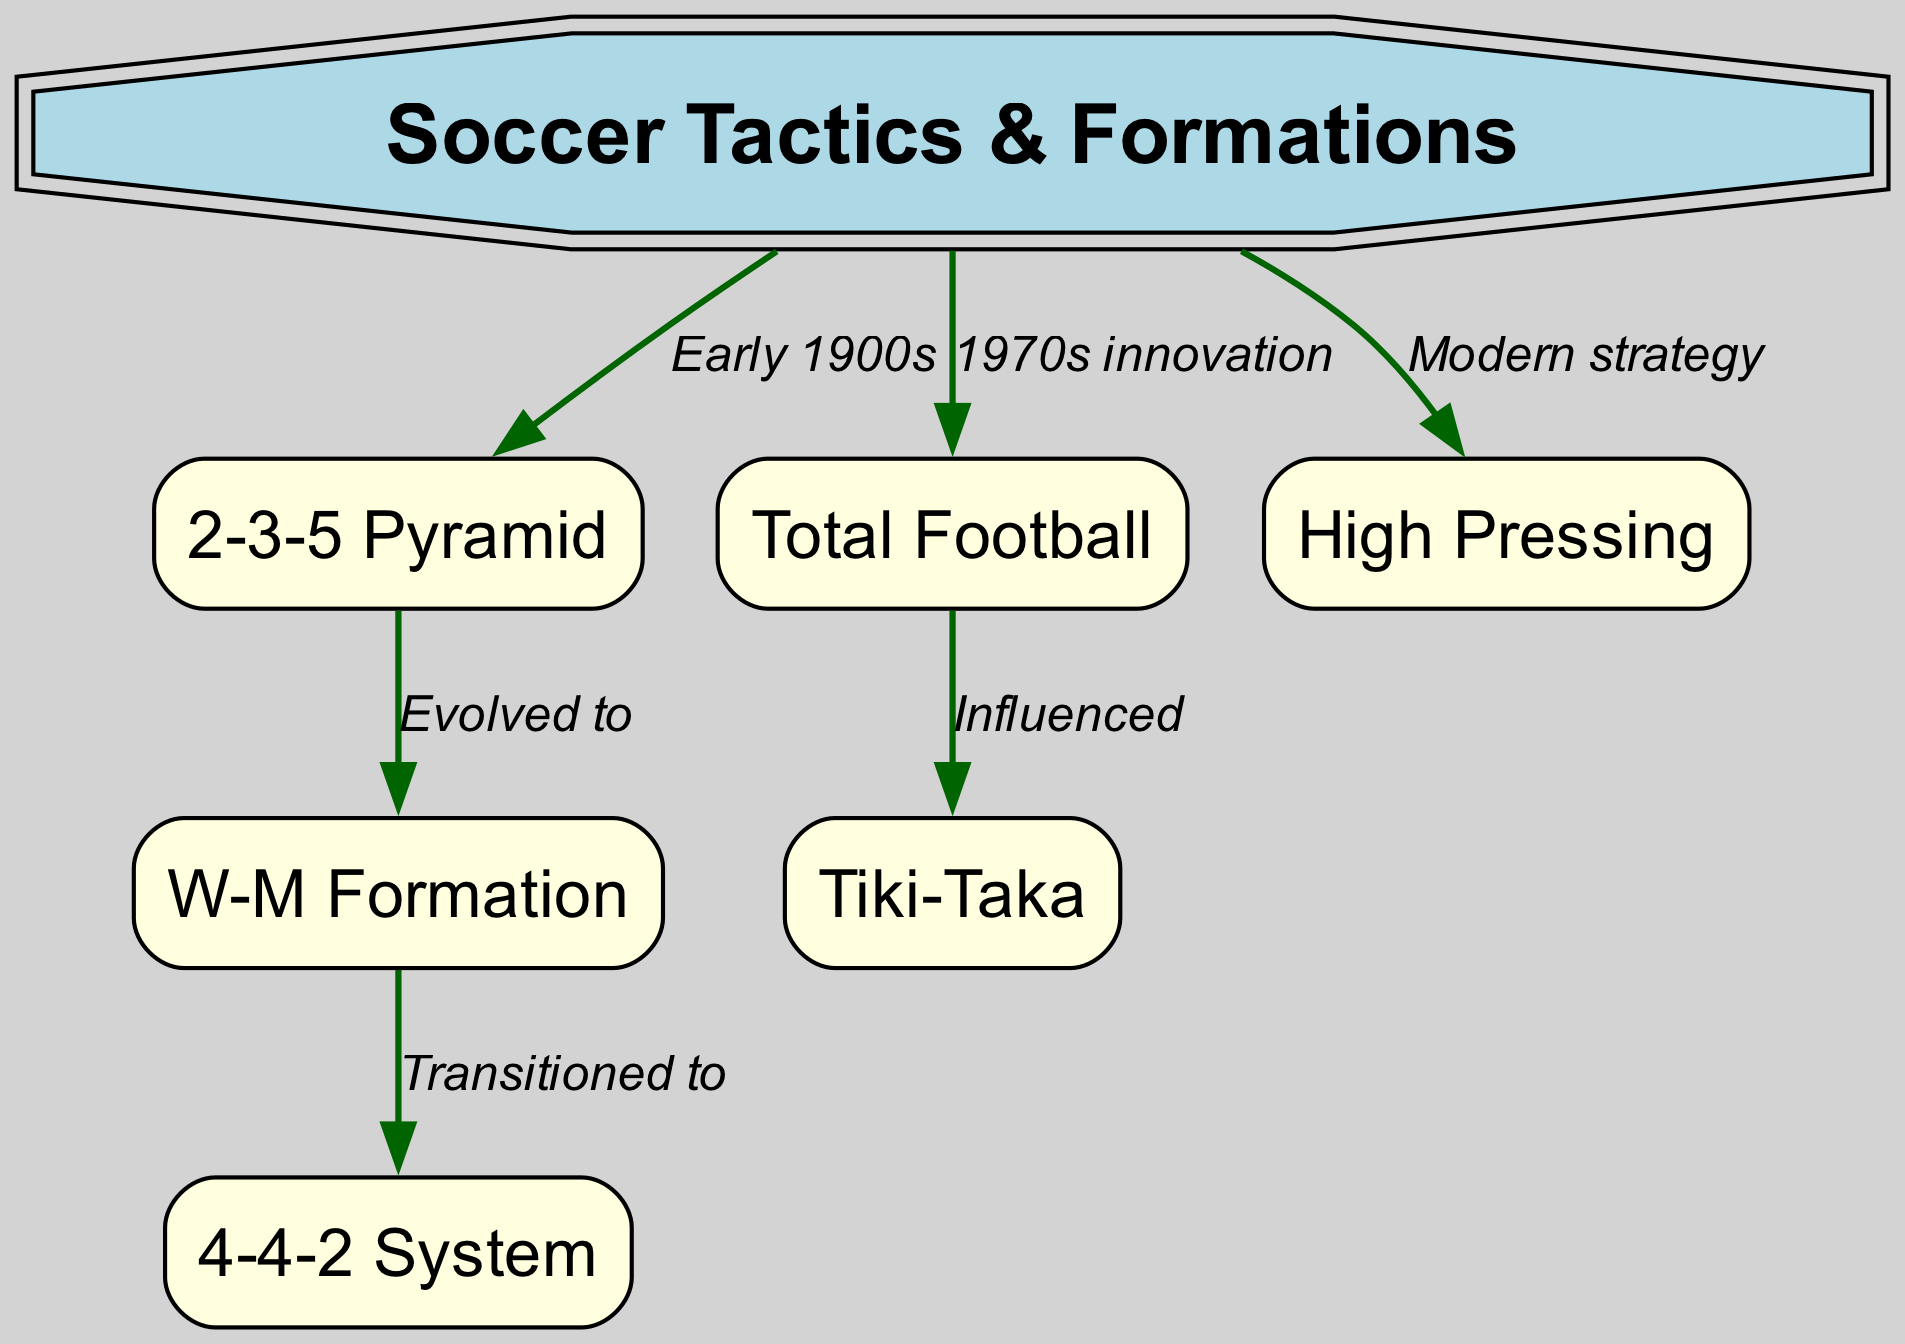What is the first formation mentioned in the diagram? The diagram lists "2-3-5 Pyramid" as the first formation directly connected to "Soccer Tactics & Formations." Since it is the first node in the relationships, it is the initial one mentioned.
Answer: 2-3-5 Pyramid How many formations are shown in the diagram? By counting the nodes related to formations, we have "2-3-5", "W-M Formation", "4-4-2 System", "Total Football", "Tiki-Taka", and "High Pressing", totaling six formations.
Answer: 6 What formation evolved from "2-3-5 Pyramid"? The diagram indicates that "W-M Formation" evolved from the "2-3-5 Pyramid" as it displays a direct connection between these two nodes.
Answer: W-M Formation Which modern strategy is connected directly to "Soccer Tactics & Formations"? The diagram connects "High Pressing" directly to "Soccer Tactics & Formations", indicating it is a modern strategy outlined in the concept map.
Answer: High Pressing What influenced "Tiki-Taka" according to the diagram? The arrow points from "Total Football" to "Tiki-Taka", indicating that "Total Football" influenced the development of "Tiki-Taka".
Answer: Total Football What formation transitioned to "4-4-2 System"? The transition from "W-M Formation" to "4-4-2 System" is marked in the diagram, which indicates the direct relationship of transition between these two formations.
Answer: W-M Formation What decade is associated with the innovation of "Total Football"? The diagram mentions that "Total Football" is an innovation from the 1970s. There are no other specific years mentioned for this concept, making it clear.
Answer: 1970s 